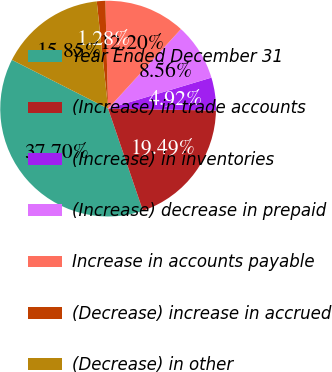<chart> <loc_0><loc_0><loc_500><loc_500><pie_chart><fcel>Year Ended December 31<fcel>(Increase) in trade accounts<fcel>(Increase) in inventories<fcel>(Increase) decrease in prepaid<fcel>Increase in accounts payable<fcel>(Decrease) increase in accrued<fcel>(Decrease) in other<nl><fcel>37.7%<fcel>19.49%<fcel>4.92%<fcel>8.56%<fcel>12.2%<fcel>1.28%<fcel>15.85%<nl></chart> 